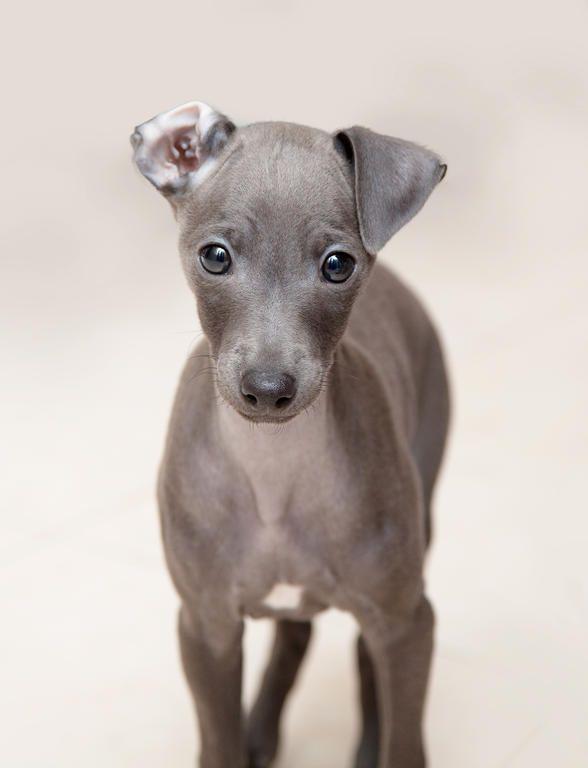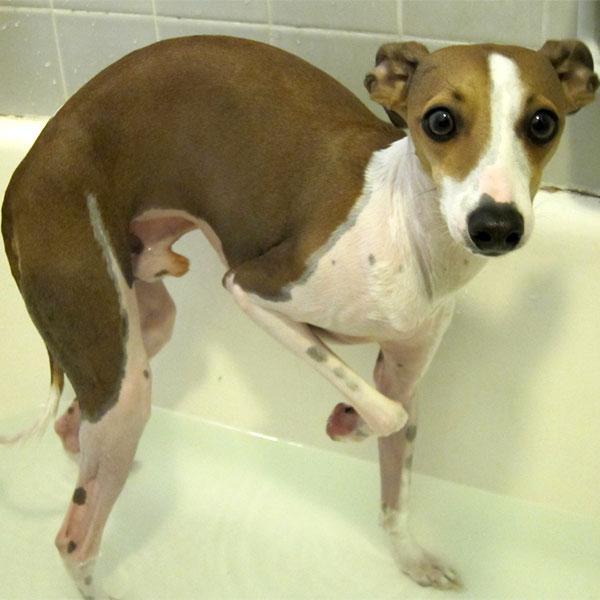The first image is the image on the left, the second image is the image on the right. Evaluate the accuracy of this statement regarding the images: "All four feet of the dog in the image on the right can be seen touching the ground.". Is it true? Answer yes or no. No. 